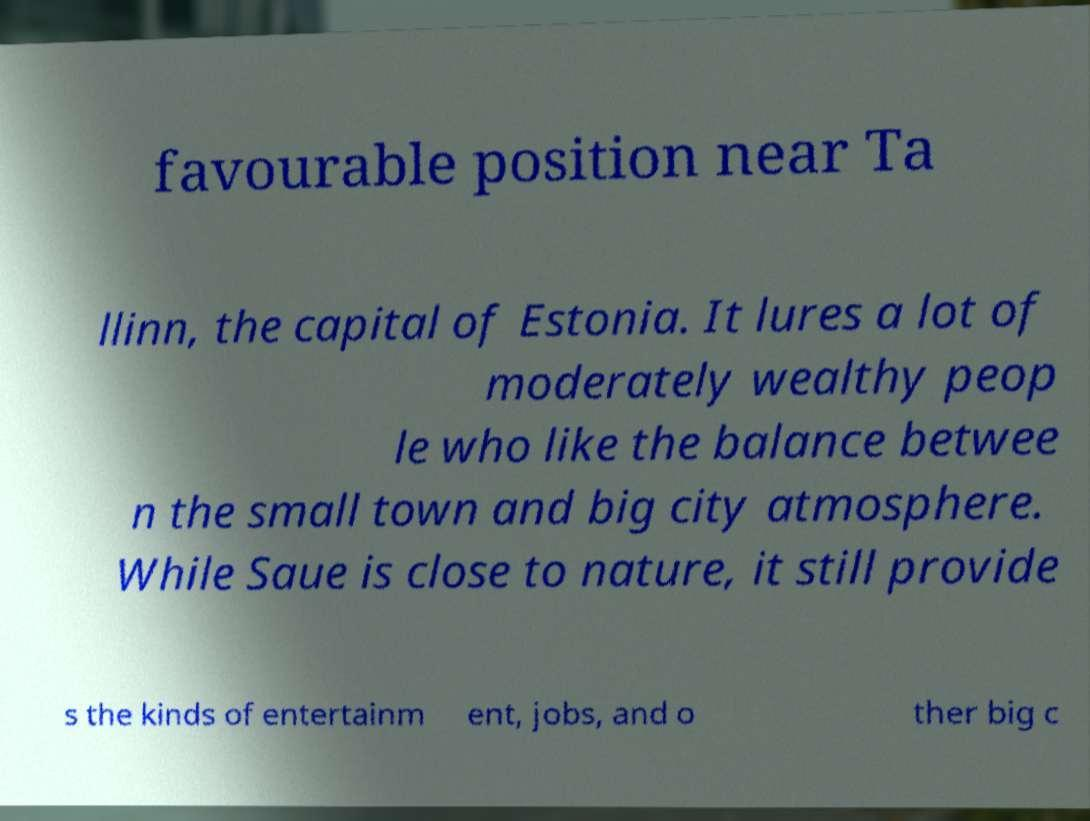Can you accurately transcribe the text from the provided image for me? favourable position near Ta llinn, the capital of Estonia. It lures a lot of moderately wealthy peop le who like the balance betwee n the small town and big city atmosphere. While Saue is close to nature, it still provide s the kinds of entertainm ent, jobs, and o ther big c 